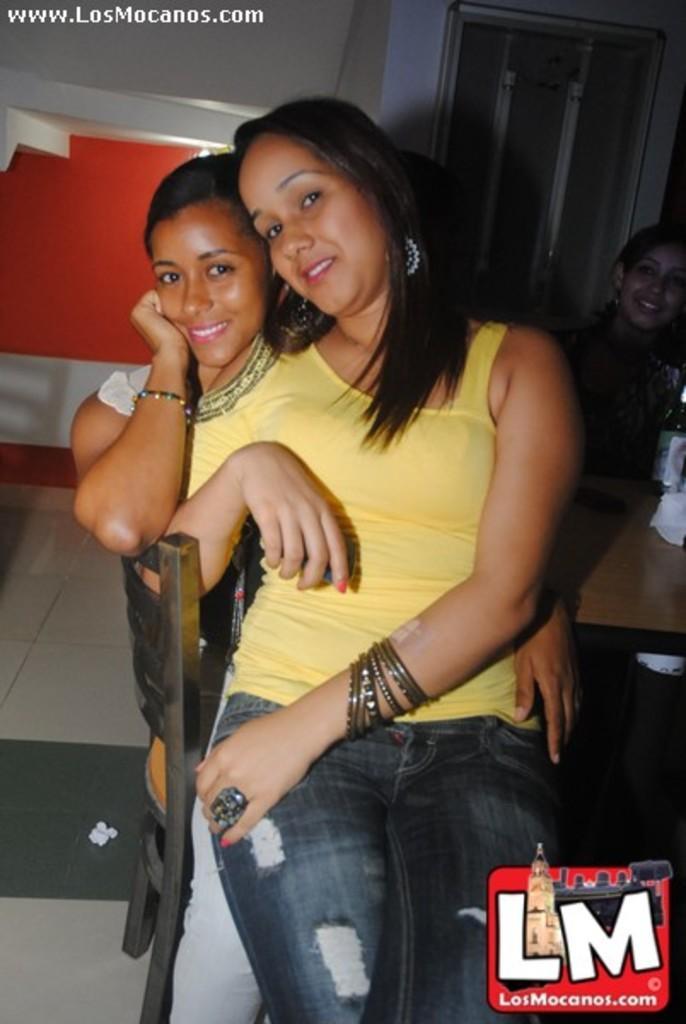Describe this image in one or two sentences. In this image there are two girls sitting on one above the other on a chair beside them there is a table. 